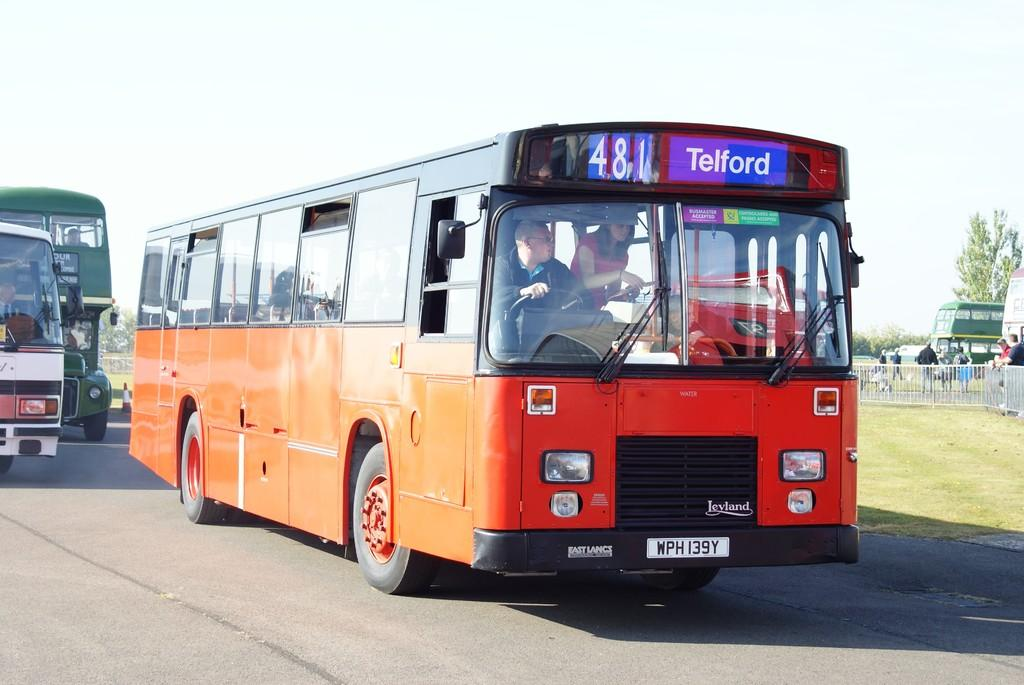Provide a one-sentence caption for the provided image. Orange bus on the road that is headed towards Telford. 